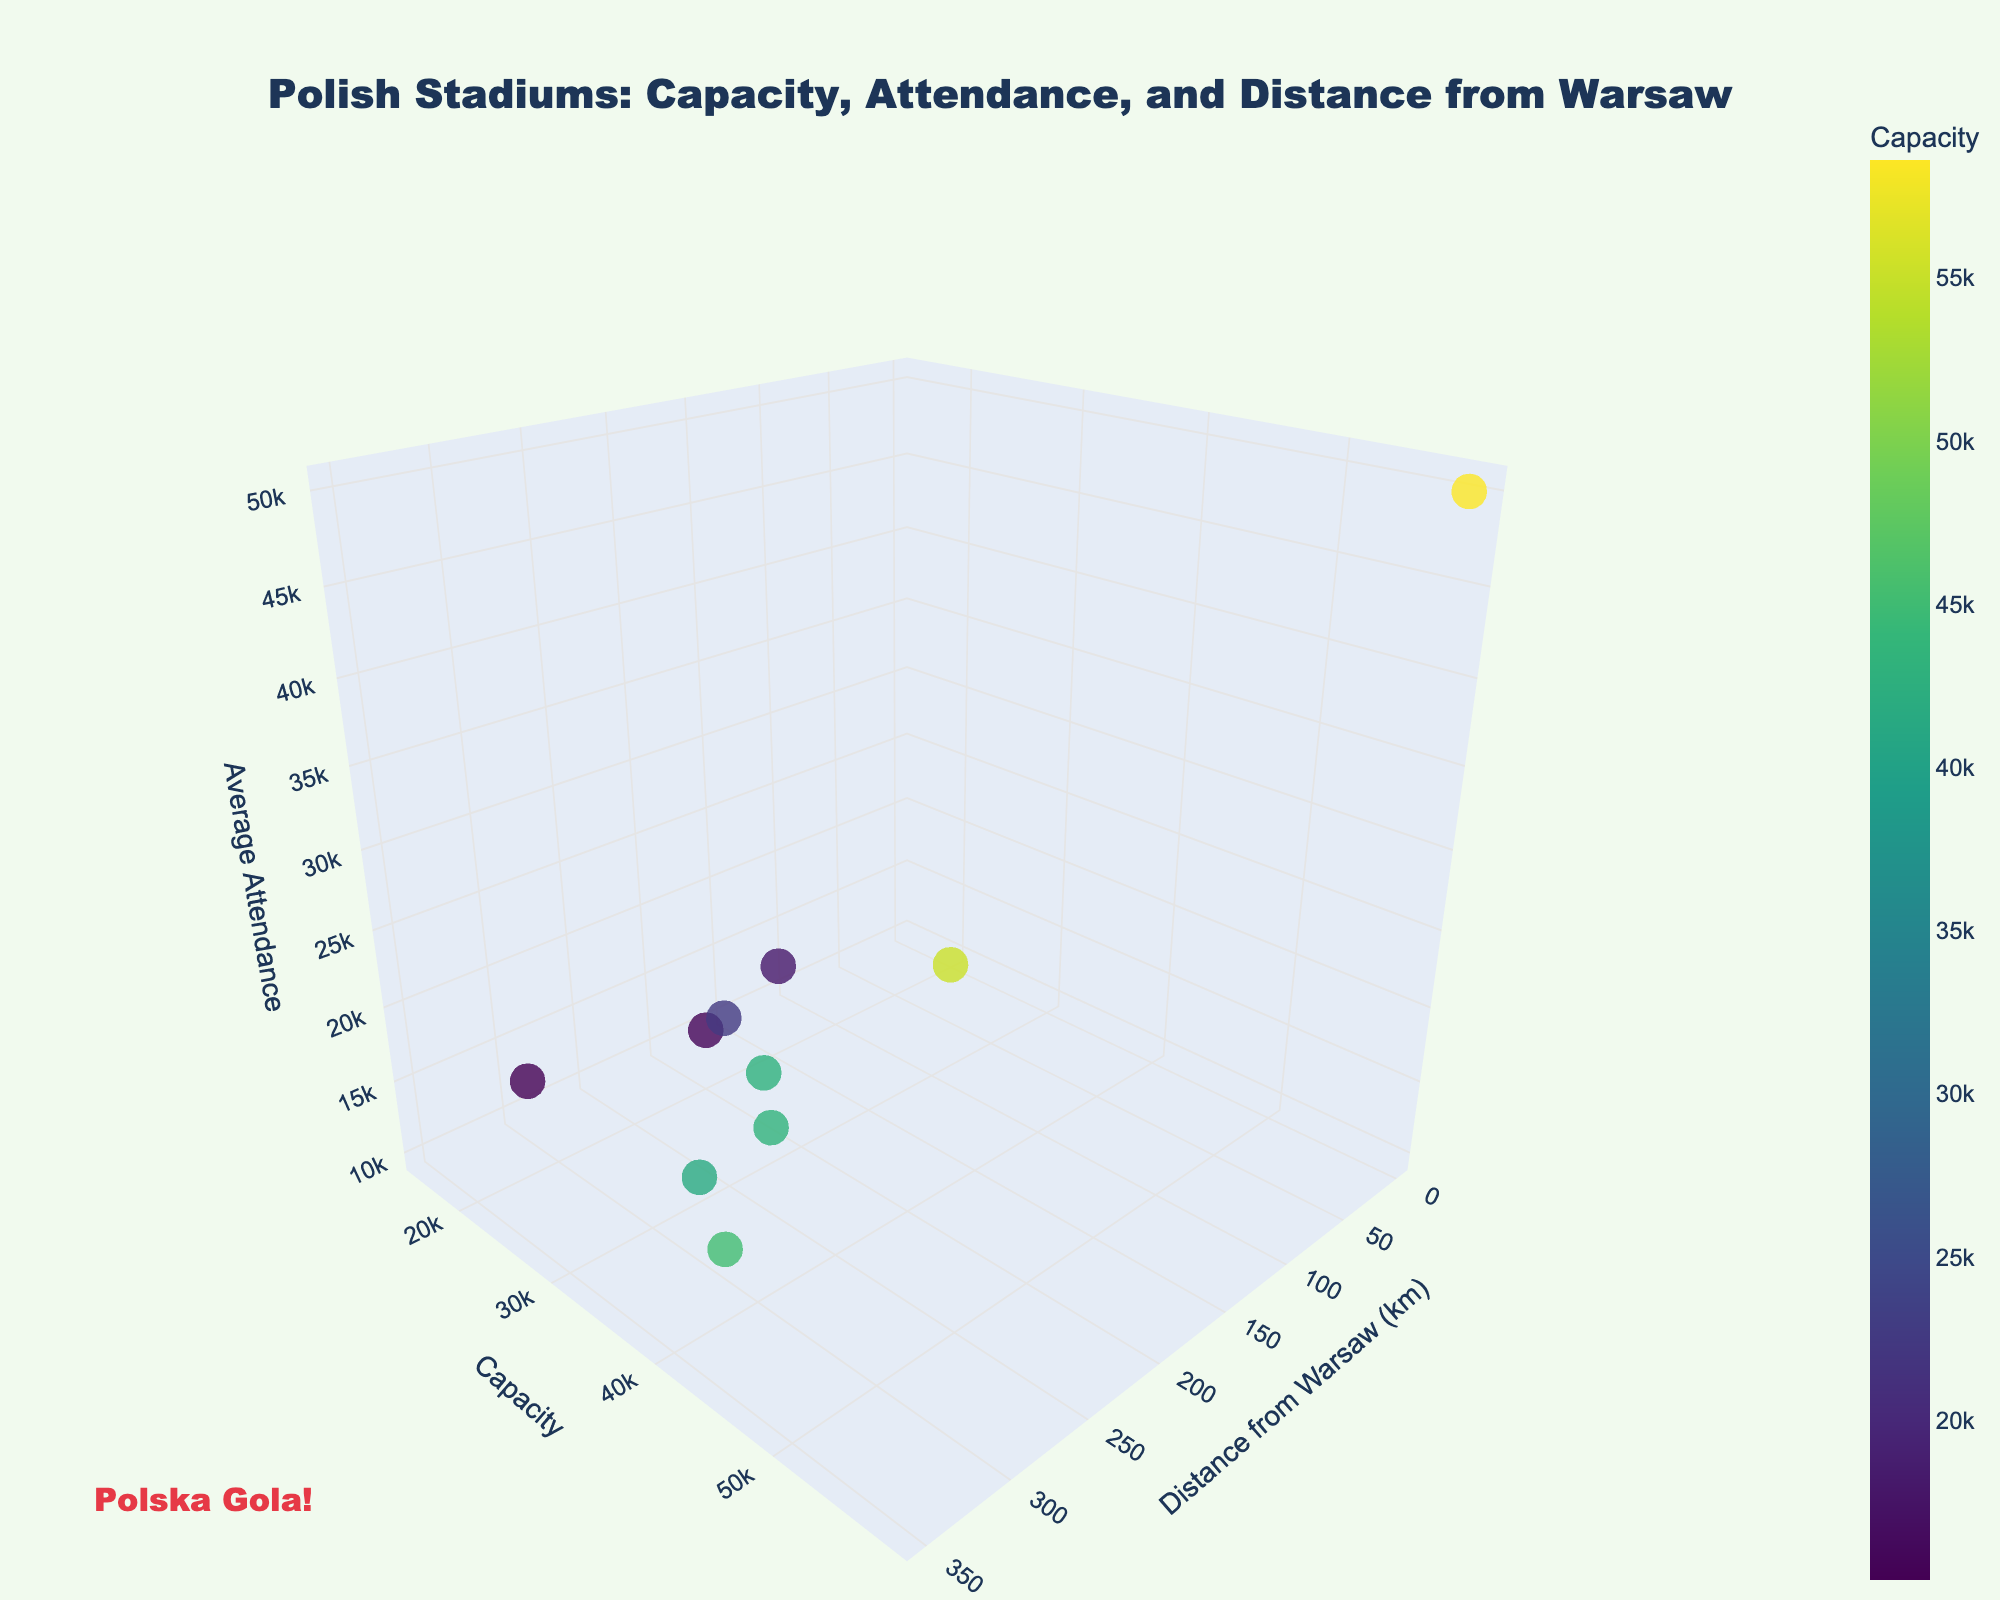What's the title of the figure? The title is displayed at the top center of the plot, indicating the main topic.
Answer: "Polish Stadiums: Capacity, Attendance, and Distance from Warsaw" Which stadium is located the farthest from Warsaw? By inspecting the x-axis (Distance from Warsaw), the farthest stadium is marked around 350 km.
Answer: Stadion Wrocław What’s the capacity of the PGE Narodowy? Hover over the point at 0 km distance from Warsaw; PGE Narodowy has its data including the capacity.
Answer: 58,580 How many stadiums have a capacity greater than 50,000? Identify points with y-values above 50,000 on the capacity axis.
Answer: 2 (PGE Narodowy and Stadion Śląski) Which stadium has the highest average attendance? The point with the highest z-value (Avg_Attendance) should be identified through hover information.
Answer: PGE Narodowy What's the average distance from Warsaw for all stadiums presented? Sum all the distances and divide by the number of stadiums: (0 + 300 + 310 + 340 + 350 + 290 + 170 + 310 + 200 + 130) / 10.
Answer: 240 km Compare Stadion Cracovii and Stadion Widzewa Łódź: which one has higher average attendance? Hover over both points and check their respective z-values (Avg_Attendance).
Answer: Stadion Cracovii What's the combined capacity of Stadion Energa Gdańsk and Stadion Wrocław? Add the capacities (y-values) of both stadiums by checking hover information: 41,620 + 45,105.
Answer: 86,725 Among the listed stadiums, how many have an average attendance below 20,000? Identify points with z-values less than 20,000.
Answer: 7 What is the color scale used to indicate in this figure? The color of each point represents the capacity of the stadiums.
Answer: Capacity 